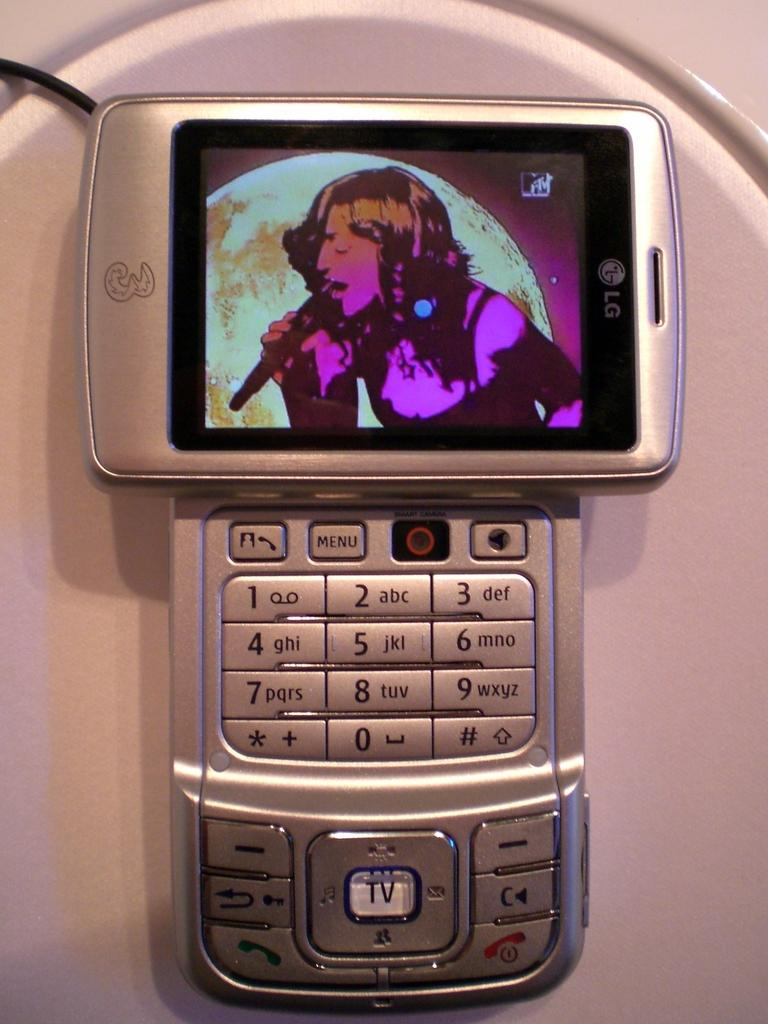Provide a one-sentence caption for the provided image. The MTV channel is shown on an LG phone. 